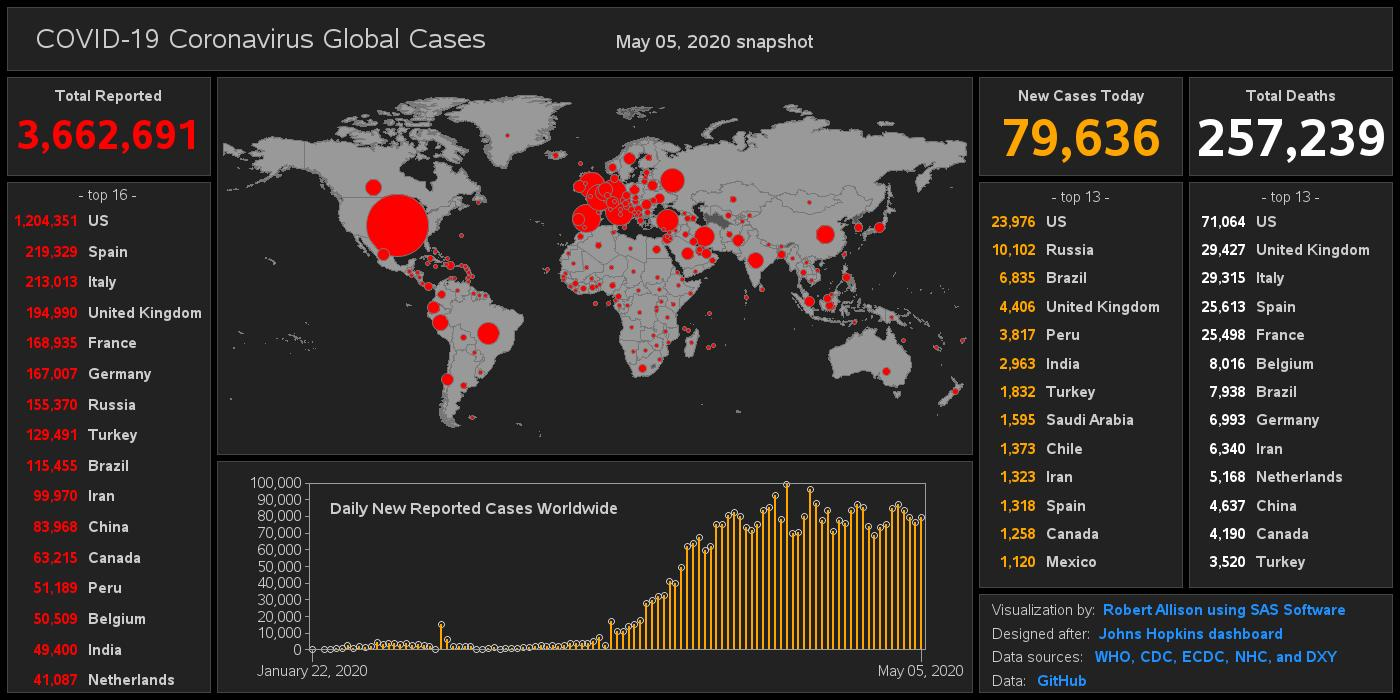Mention a couple of crucial points in this snapshot. As of May 05, 2020, a total of 29,315 Covid-19 deaths had been reported in Italy. As of May 05, 2020, the total number of COVID-19 cases reported globally was 3,662,691. According to the most recent data available as of May 05, 2020, the Netherlands has reported the lowest number of COVID-19 cases among the top 16 countries. The country with the highest number of COVID-19 deaths among the top 13 countries as of May 05, 2020, has not been reported. As of May 05, 2020, there were 2,963 new cases of Covid-19 reported in India. 